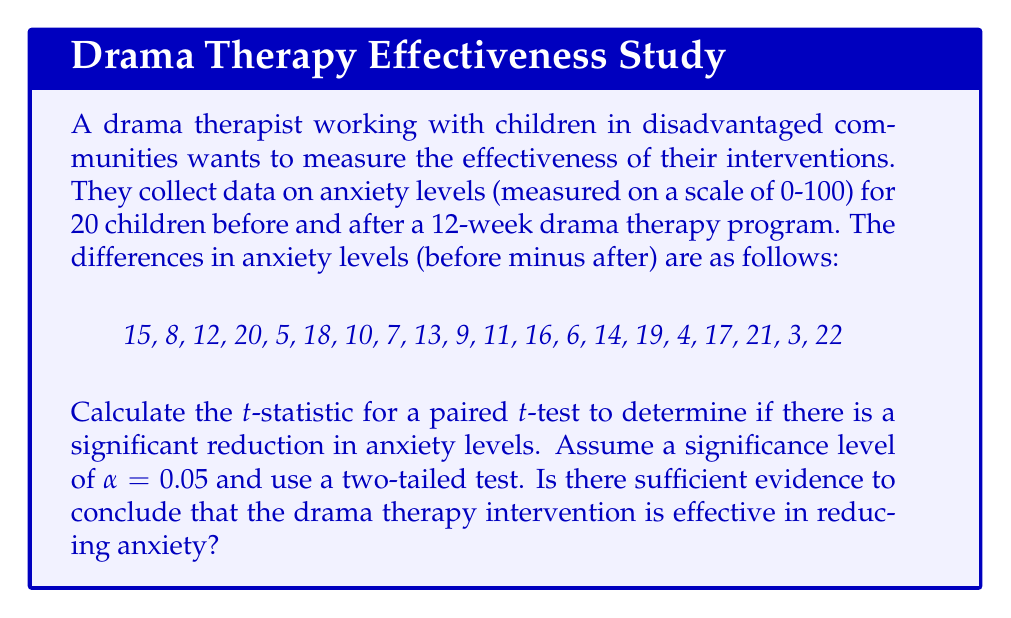Show me your answer to this math problem. To calculate the t-statistic and determine the effectiveness of the drama therapy intervention, we'll follow these steps:

1. Calculate the mean difference:
   $$\bar{d} = \frac{\sum_{i=1}^{n} d_i}{n} = \frac{250}{20} = 12.5$$

2. Calculate the standard deviation of the differences:
   $$s_d = \sqrt{\frac{\sum_{i=1}^{n} (d_i - \bar{d})^2}{n-1}}$$
   
   $$s_d = \sqrt{\frac{840.5}{19}} \approx 6.65$$

3. Calculate the standard error of the mean difference:
   $$SE_{\bar{d}} = \frac{s_d}{\sqrt{n}} = \frac{6.65}{\sqrt{20}} \approx 1.49$$

4. Calculate the t-statistic:
   $$t = \frac{\bar{d}}{SE_{\bar{d}}} = \frac{12.5}{1.49} \approx 8.39$$

5. Determine the critical t-value:
   For a two-tailed test with α = 0.05 and df = 19, t_critical ≈ ±2.093

6. Compare the calculated t-statistic to the critical t-value:
   |8.39| > 2.093, so we reject the null hypothesis.

7. Calculate the p-value:
   p-value < 0.0001 (using t-distribution tables or software)

Since the calculated t-statistic (8.39) is greater than the critical t-value (2.093) and the p-value is less than the significance level (0.05), we have sufficient evidence to conclude that the drama therapy intervention is effective in reducing anxiety levels.
Answer: t = 8.39; p < 0.0001; Effective 